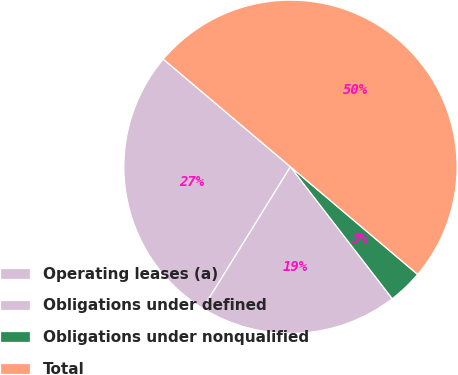Convert chart. <chart><loc_0><loc_0><loc_500><loc_500><pie_chart><fcel>Operating leases (a)<fcel>Obligations under defined<fcel>Obligations under nonqualified<fcel>Total<nl><fcel>27.36%<fcel>19.28%<fcel>3.36%<fcel>50.0%<nl></chart> 